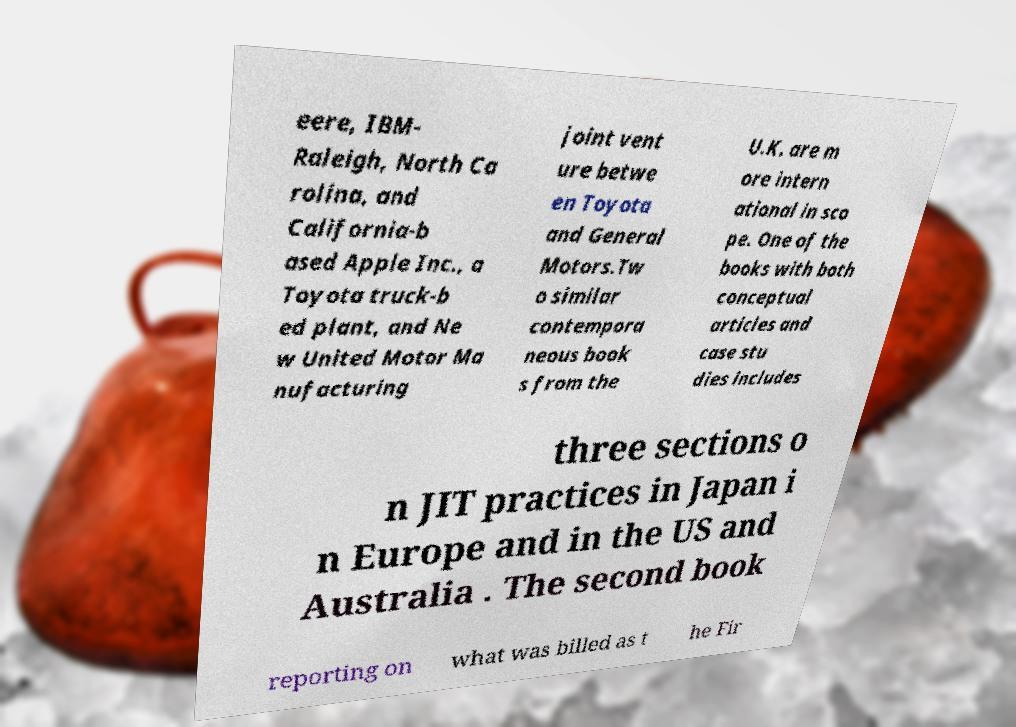What messages or text are displayed in this image? I need them in a readable, typed format. eere, IBM- Raleigh, North Ca rolina, and California-b ased Apple Inc., a Toyota truck-b ed plant, and Ne w United Motor Ma nufacturing joint vent ure betwe en Toyota and General Motors.Tw o similar contempora neous book s from the U.K. are m ore intern ational in sco pe. One of the books with both conceptual articles and case stu dies includes three sections o n JIT practices in Japan i n Europe and in the US and Australia . The second book reporting on what was billed as t he Fir 